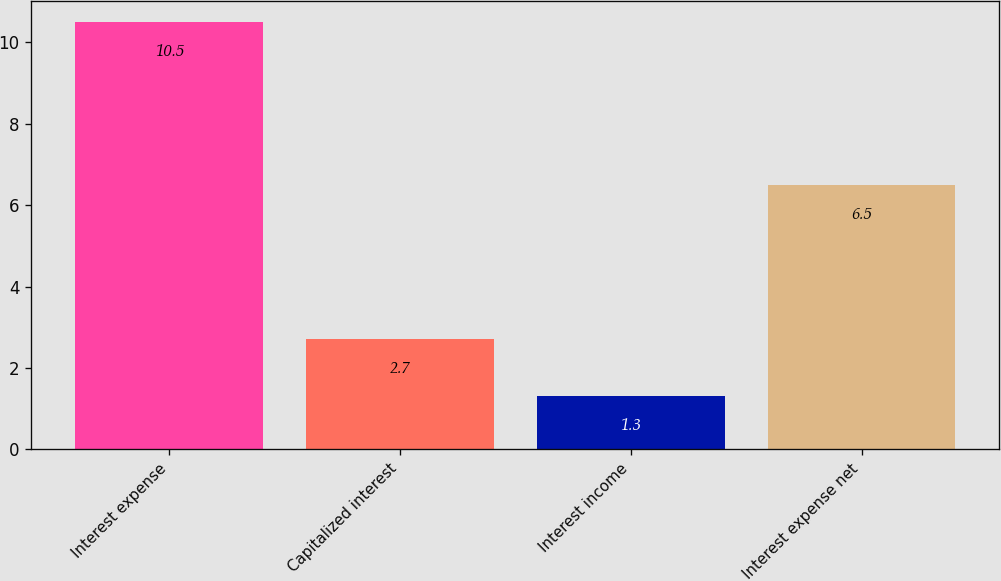Convert chart. <chart><loc_0><loc_0><loc_500><loc_500><bar_chart><fcel>Interest expense<fcel>Capitalized interest<fcel>Interest income<fcel>Interest expense net<nl><fcel>10.5<fcel>2.7<fcel>1.3<fcel>6.5<nl></chart> 